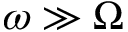Convert formula to latex. <formula><loc_0><loc_0><loc_500><loc_500>\omega \gg \Omega</formula> 